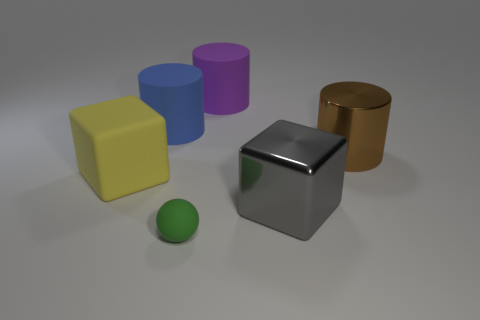Are there any objects in the image that could be a container for the others? The large brown cylinder on the far right looks like it could potentially serve as a container for the small green sphere, but it would not be suitable for the other larger objects. 